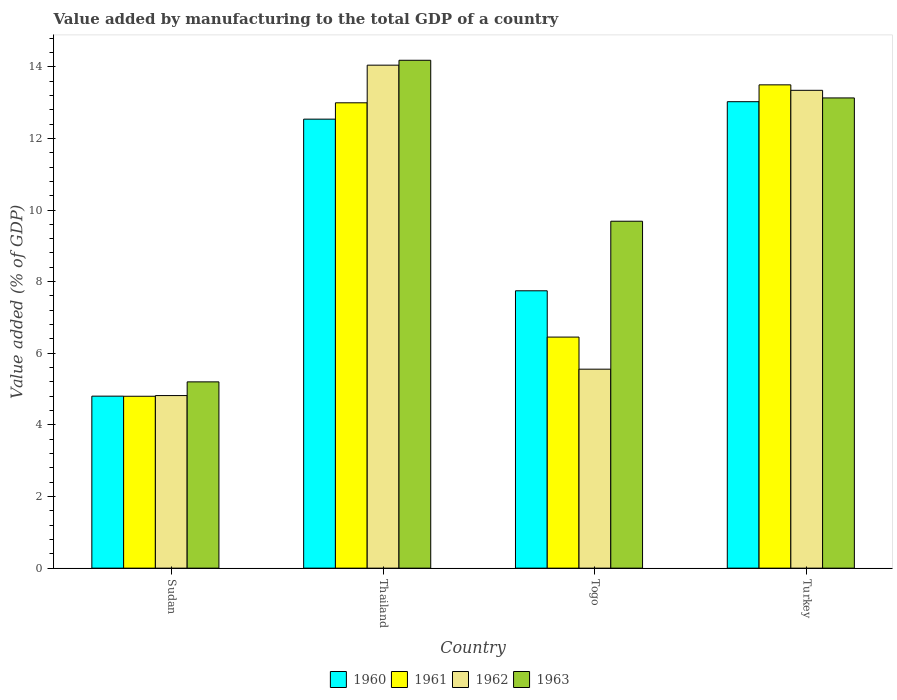How many groups of bars are there?
Your answer should be compact. 4. Are the number of bars per tick equal to the number of legend labels?
Make the answer very short. Yes. What is the label of the 1st group of bars from the left?
Your answer should be very brief. Sudan. What is the value added by manufacturing to the total GDP in 1960 in Turkey?
Make the answer very short. 13.02. Across all countries, what is the maximum value added by manufacturing to the total GDP in 1960?
Give a very brief answer. 13.02. Across all countries, what is the minimum value added by manufacturing to the total GDP in 1963?
Your response must be concise. 5.2. In which country was the value added by manufacturing to the total GDP in 1960 maximum?
Offer a very short reply. Turkey. In which country was the value added by manufacturing to the total GDP in 1962 minimum?
Your response must be concise. Sudan. What is the total value added by manufacturing to the total GDP in 1963 in the graph?
Provide a succinct answer. 42.2. What is the difference between the value added by manufacturing to the total GDP in 1962 in Sudan and that in Thailand?
Offer a very short reply. -9.23. What is the difference between the value added by manufacturing to the total GDP in 1962 in Sudan and the value added by manufacturing to the total GDP in 1960 in Thailand?
Your response must be concise. -7.72. What is the average value added by manufacturing to the total GDP in 1963 per country?
Your answer should be very brief. 10.55. What is the difference between the value added by manufacturing to the total GDP of/in 1961 and value added by manufacturing to the total GDP of/in 1962 in Thailand?
Your answer should be very brief. -1.05. What is the ratio of the value added by manufacturing to the total GDP in 1960 in Sudan to that in Togo?
Your answer should be very brief. 0.62. Is the value added by manufacturing to the total GDP in 1963 in Togo less than that in Turkey?
Keep it short and to the point. Yes. Is the difference between the value added by manufacturing to the total GDP in 1961 in Sudan and Togo greater than the difference between the value added by manufacturing to the total GDP in 1962 in Sudan and Togo?
Offer a terse response. No. What is the difference between the highest and the second highest value added by manufacturing to the total GDP in 1962?
Keep it short and to the point. -7.79. What is the difference between the highest and the lowest value added by manufacturing to the total GDP in 1963?
Your answer should be very brief. 8.98. In how many countries, is the value added by manufacturing to the total GDP in 1961 greater than the average value added by manufacturing to the total GDP in 1961 taken over all countries?
Keep it short and to the point. 2. Is it the case that in every country, the sum of the value added by manufacturing to the total GDP in 1963 and value added by manufacturing to the total GDP in 1961 is greater than the sum of value added by manufacturing to the total GDP in 1962 and value added by manufacturing to the total GDP in 1960?
Your response must be concise. No. What does the 4th bar from the right in Sudan represents?
Give a very brief answer. 1960. How many countries are there in the graph?
Give a very brief answer. 4. What is the difference between two consecutive major ticks on the Y-axis?
Your response must be concise. 2. Does the graph contain any zero values?
Provide a succinct answer. No. Does the graph contain grids?
Offer a terse response. No. What is the title of the graph?
Offer a terse response. Value added by manufacturing to the total GDP of a country. What is the label or title of the Y-axis?
Your answer should be compact. Value added (% of GDP). What is the Value added (% of GDP) of 1960 in Sudan?
Offer a very short reply. 4.8. What is the Value added (% of GDP) of 1961 in Sudan?
Give a very brief answer. 4.8. What is the Value added (% of GDP) of 1962 in Sudan?
Your answer should be compact. 4.82. What is the Value added (% of GDP) of 1963 in Sudan?
Your response must be concise. 5.2. What is the Value added (% of GDP) of 1960 in Thailand?
Your answer should be compact. 12.54. What is the Value added (% of GDP) in 1961 in Thailand?
Keep it short and to the point. 12.99. What is the Value added (% of GDP) of 1962 in Thailand?
Your answer should be very brief. 14.04. What is the Value added (% of GDP) in 1963 in Thailand?
Your answer should be compact. 14.18. What is the Value added (% of GDP) of 1960 in Togo?
Keep it short and to the point. 7.74. What is the Value added (% of GDP) in 1961 in Togo?
Provide a short and direct response. 6.45. What is the Value added (% of GDP) in 1962 in Togo?
Make the answer very short. 5.56. What is the Value added (% of GDP) of 1963 in Togo?
Provide a short and direct response. 9.69. What is the Value added (% of GDP) in 1960 in Turkey?
Your answer should be very brief. 13.02. What is the Value added (% of GDP) in 1961 in Turkey?
Your response must be concise. 13.49. What is the Value added (% of GDP) in 1962 in Turkey?
Your answer should be very brief. 13.34. What is the Value added (% of GDP) of 1963 in Turkey?
Offer a terse response. 13.13. Across all countries, what is the maximum Value added (% of GDP) in 1960?
Make the answer very short. 13.02. Across all countries, what is the maximum Value added (% of GDP) of 1961?
Your answer should be very brief. 13.49. Across all countries, what is the maximum Value added (% of GDP) of 1962?
Your answer should be compact. 14.04. Across all countries, what is the maximum Value added (% of GDP) in 1963?
Provide a short and direct response. 14.18. Across all countries, what is the minimum Value added (% of GDP) of 1960?
Give a very brief answer. 4.8. Across all countries, what is the minimum Value added (% of GDP) of 1961?
Ensure brevity in your answer.  4.8. Across all countries, what is the minimum Value added (% of GDP) of 1962?
Provide a succinct answer. 4.82. Across all countries, what is the minimum Value added (% of GDP) of 1963?
Your answer should be compact. 5.2. What is the total Value added (% of GDP) in 1960 in the graph?
Provide a short and direct response. 38.11. What is the total Value added (% of GDP) of 1961 in the graph?
Keep it short and to the point. 37.74. What is the total Value added (% of GDP) of 1962 in the graph?
Offer a very short reply. 37.76. What is the total Value added (% of GDP) in 1963 in the graph?
Your response must be concise. 42.2. What is the difference between the Value added (% of GDP) in 1960 in Sudan and that in Thailand?
Offer a terse response. -7.73. What is the difference between the Value added (% of GDP) in 1961 in Sudan and that in Thailand?
Provide a short and direct response. -8.19. What is the difference between the Value added (% of GDP) of 1962 in Sudan and that in Thailand?
Your answer should be compact. -9.23. What is the difference between the Value added (% of GDP) in 1963 in Sudan and that in Thailand?
Provide a short and direct response. -8.98. What is the difference between the Value added (% of GDP) in 1960 in Sudan and that in Togo?
Ensure brevity in your answer.  -2.94. What is the difference between the Value added (% of GDP) of 1961 in Sudan and that in Togo?
Provide a succinct answer. -1.65. What is the difference between the Value added (% of GDP) of 1962 in Sudan and that in Togo?
Provide a short and direct response. -0.74. What is the difference between the Value added (% of GDP) of 1963 in Sudan and that in Togo?
Provide a short and direct response. -4.49. What is the difference between the Value added (% of GDP) in 1960 in Sudan and that in Turkey?
Provide a short and direct response. -8.22. What is the difference between the Value added (% of GDP) in 1961 in Sudan and that in Turkey?
Offer a terse response. -8.69. What is the difference between the Value added (% of GDP) of 1962 in Sudan and that in Turkey?
Provide a succinct answer. -8.52. What is the difference between the Value added (% of GDP) of 1963 in Sudan and that in Turkey?
Ensure brevity in your answer.  -7.93. What is the difference between the Value added (% of GDP) of 1960 in Thailand and that in Togo?
Your response must be concise. 4.79. What is the difference between the Value added (% of GDP) of 1961 in Thailand and that in Togo?
Provide a succinct answer. 6.54. What is the difference between the Value added (% of GDP) of 1962 in Thailand and that in Togo?
Ensure brevity in your answer.  8.49. What is the difference between the Value added (% of GDP) in 1963 in Thailand and that in Togo?
Offer a terse response. 4.49. What is the difference between the Value added (% of GDP) of 1960 in Thailand and that in Turkey?
Your answer should be very brief. -0.49. What is the difference between the Value added (% of GDP) in 1961 in Thailand and that in Turkey?
Keep it short and to the point. -0.5. What is the difference between the Value added (% of GDP) of 1962 in Thailand and that in Turkey?
Offer a terse response. 0.7. What is the difference between the Value added (% of GDP) in 1963 in Thailand and that in Turkey?
Make the answer very short. 1.05. What is the difference between the Value added (% of GDP) in 1960 in Togo and that in Turkey?
Provide a succinct answer. -5.28. What is the difference between the Value added (% of GDP) of 1961 in Togo and that in Turkey?
Give a very brief answer. -7.04. What is the difference between the Value added (% of GDP) in 1962 in Togo and that in Turkey?
Give a very brief answer. -7.79. What is the difference between the Value added (% of GDP) of 1963 in Togo and that in Turkey?
Your response must be concise. -3.44. What is the difference between the Value added (% of GDP) of 1960 in Sudan and the Value added (% of GDP) of 1961 in Thailand?
Provide a succinct answer. -8.19. What is the difference between the Value added (% of GDP) of 1960 in Sudan and the Value added (% of GDP) of 1962 in Thailand?
Provide a short and direct response. -9.24. What is the difference between the Value added (% of GDP) in 1960 in Sudan and the Value added (% of GDP) in 1963 in Thailand?
Offer a very short reply. -9.38. What is the difference between the Value added (% of GDP) of 1961 in Sudan and the Value added (% of GDP) of 1962 in Thailand?
Offer a very short reply. -9.24. What is the difference between the Value added (% of GDP) in 1961 in Sudan and the Value added (% of GDP) in 1963 in Thailand?
Make the answer very short. -9.38. What is the difference between the Value added (% of GDP) of 1962 in Sudan and the Value added (% of GDP) of 1963 in Thailand?
Offer a terse response. -9.36. What is the difference between the Value added (% of GDP) in 1960 in Sudan and the Value added (% of GDP) in 1961 in Togo?
Ensure brevity in your answer.  -1.65. What is the difference between the Value added (% of GDP) in 1960 in Sudan and the Value added (% of GDP) in 1962 in Togo?
Provide a succinct answer. -0.75. What is the difference between the Value added (% of GDP) of 1960 in Sudan and the Value added (% of GDP) of 1963 in Togo?
Provide a succinct answer. -4.88. What is the difference between the Value added (% of GDP) in 1961 in Sudan and the Value added (% of GDP) in 1962 in Togo?
Make the answer very short. -0.76. What is the difference between the Value added (% of GDP) of 1961 in Sudan and the Value added (% of GDP) of 1963 in Togo?
Provide a succinct answer. -4.89. What is the difference between the Value added (% of GDP) of 1962 in Sudan and the Value added (% of GDP) of 1963 in Togo?
Make the answer very short. -4.87. What is the difference between the Value added (% of GDP) in 1960 in Sudan and the Value added (% of GDP) in 1961 in Turkey?
Provide a short and direct response. -8.69. What is the difference between the Value added (% of GDP) of 1960 in Sudan and the Value added (% of GDP) of 1962 in Turkey?
Your answer should be very brief. -8.54. What is the difference between the Value added (% of GDP) in 1960 in Sudan and the Value added (% of GDP) in 1963 in Turkey?
Your answer should be very brief. -8.33. What is the difference between the Value added (% of GDP) of 1961 in Sudan and the Value added (% of GDP) of 1962 in Turkey?
Your response must be concise. -8.54. What is the difference between the Value added (% of GDP) in 1961 in Sudan and the Value added (% of GDP) in 1963 in Turkey?
Offer a terse response. -8.33. What is the difference between the Value added (% of GDP) in 1962 in Sudan and the Value added (% of GDP) in 1963 in Turkey?
Offer a terse response. -8.31. What is the difference between the Value added (% of GDP) of 1960 in Thailand and the Value added (% of GDP) of 1961 in Togo?
Ensure brevity in your answer.  6.09. What is the difference between the Value added (% of GDP) of 1960 in Thailand and the Value added (% of GDP) of 1962 in Togo?
Offer a terse response. 6.98. What is the difference between the Value added (% of GDP) of 1960 in Thailand and the Value added (% of GDP) of 1963 in Togo?
Offer a very short reply. 2.85. What is the difference between the Value added (% of GDP) in 1961 in Thailand and the Value added (% of GDP) in 1962 in Togo?
Offer a terse response. 7.44. What is the difference between the Value added (% of GDP) of 1961 in Thailand and the Value added (% of GDP) of 1963 in Togo?
Your response must be concise. 3.31. What is the difference between the Value added (% of GDP) of 1962 in Thailand and the Value added (% of GDP) of 1963 in Togo?
Your response must be concise. 4.36. What is the difference between the Value added (% of GDP) of 1960 in Thailand and the Value added (% of GDP) of 1961 in Turkey?
Offer a terse response. -0.96. What is the difference between the Value added (% of GDP) of 1960 in Thailand and the Value added (% of GDP) of 1962 in Turkey?
Your answer should be compact. -0.81. What is the difference between the Value added (% of GDP) of 1960 in Thailand and the Value added (% of GDP) of 1963 in Turkey?
Your answer should be very brief. -0.59. What is the difference between the Value added (% of GDP) in 1961 in Thailand and the Value added (% of GDP) in 1962 in Turkey?
Offer a terse response. -0.35. What is the difference between the Value added (% of GDP) in 1961 in Thailand and the Value added (% of GDP) in 1963 in Turkey?
Offer a terse response. -0.14. What is the difference between the Value added (% of GDP) of 1962 in Thailand and the Value added (% of GDP) of 1963 in Turkey?
Your answer should be compact. 0.92. What is the difference between the Value added (% of GDP) of 1960 in Togo and the Value added (% of GDP) of 1961 in Turkey?
Your response must be concise. -5.75. What is the difference between the Value added (% of GDP) in 1960 in Togo and the Value added (% of GDP) in 1962 in Turkey?
Your response must be concise. -5.6. What is the difference between the Value added (% of GDP) in 1960 in Togo and the Value added (% of GDP) in 1963 in Turkey?
Provide a succinct answer. -5.38. What is the difference between the Value added (% of GDP) in 1961 in Togo and the Value added (% of GDP) in 1962 in Turkey?
Provide a short and direct response. -6.89. What is the difference between the Value added (% of GDP) in 1961 in Togo and the Value added (% of GDP) in 1963 in Turkey?
Offer a very short reply. -6.68. What is the difference between the Value added (% of GDP) of 1962 in Togo and the Value added (% of GDP) of 1963 in Turkey?
Provide a short and direct response. -7.57. What is the average Value added (% of GDP) of 1960 per country?
Provide a short and direct response. 9.53. What is the average Value added (% of GDP) of 1961 per country?
Offer a terse response. 9.43. What is the average Value added (% of GDP) of 1962 per country?
Keep it short and to the point. 9.44. What is the average Value added (% of GDP) of 1963 per country?
Offer a terse response. 10.55. What is the difference between the Value added (% of GDP) of 1960 and Value added (% of GDP) of 1961 in Sudan?
Your answer should be very brief. 0. What is the difference between the Value added (% of GDP) in 1960 and Value added (% of GDP) in 1962 in Sudan?
Keep it short and to the point. -0.02. What is the difference between the Value added (% of GDP) in 1960 and Value added (% of GDP) in 1963 in Sudan?
Ensure brevity in your answer.  -0.4. What is the difference between the Value added (% of GDP) in 1961 and Value added (% of GDP) in 1962 in Sudan?
Provide a succinct answer. -0.02. What is the difference between the Value added (% of GDP) in 1961 and Value added (% of GDP) in 1963 in Sudan?
Your answer should be very brief. -0.4. What is the difference between the Value added (% of GDP) of 1962 and Value added (% of GDP) of 1963 in Sudan?
Offer a terse response. -0.38. What is the difference between the Value added (% of GDP) in 1960 and Value added (% of GDP) in 1961 in Thailand?
Offer a terse response. -0.46. What is the difference between the Value added (% of GDP) in 1960 and Value added (% of GDP) in 1962 in Thailand?
Provide a succinct answer. -1.51. What is the difference between the Value added (% of GDP) in 1960 and Value added (% of GDP) in 1963 in Thailand?
Provide a succinct answer. -1.64. What is the difference between the Value added (% of GDP) of 1961 and Value added (% of GDP) of 1962 in Thailand?
Provide a succinct answer. -1.05. What is the difference between the Value added (% of GDP) in 1961 and Value added (% of GDP) in 1963 in Thailand?
Make the answer very short. -1.19. What is the difference between the Value added (% of GDP) in 1962 and Value added (% of GDP) in 1963 in Thailand?
Make the answer very short. -0.14. What is the difference between the Value added (% of GDP) in 1960 and Value added (% of GDP) in 1961 in Togo?
Provide a succinct answer. 1.29. What is the difference between the Value added (% of GDP) of 1960 and Value added (% of GDP) of 1962 in Togo?
Offer a very short reply. 2.19. What is the difference between the Value added (% of GDP) of 1960 and Value added (% of GDP) of 1963 in Togo?
Your answer should be very brief. -1.94. What is the difference between the Value added (% of GDP) in 1961 and Value added (% of GDP) in 1962 in Togo?
Make the answer very short. 0.9. What is the difference between the Value added (% of GDP) of 1961 and Value added (% of GDP) of 1963 in Togo?
Your answer should be compact. -3.23. What is the difference between the Value added (% of GDP) of 1962 and Value added (% of GDP) of 1963 in Togo?
Give a very brief answer. -4.13. What is the difference between the Value added (% of GDP) in 1960 and Value added (% of GDP) in 1961 in Turkey?
Keep it short and to the point. -0.47. What is the difference between the Value added (% of GDP) in 1960 and Value added (% of GDP) in 1962 in Turkey?
Your response must be concise. -0.32. What is the difference between the Value added (% of GDP) in 1960 and Value added (% of GDP) in 1963 in Turkey?
Offer a very short reply. -0.11. What is the difference between the Value added (% of GDP) in 1961 and Value added (% of GDP) in 1962 in Turkey?
Offer a very short reply. 0.15. What is the difference between the Value added (% of GDP) in 1961 and Value added (% of GDP) in 1963 in Turkey?
Ensure brevity in your answer.  0.37. What is the difference between the Value added (% of GDP) of 1962 and Value added (% of GDP) of 1963 in Turkey?
Give a very brief answer. 0.21. What is the ratio of the Value added (% of GDP) of 1960 in Sudan to that in Thailand?
Provide a succinct answer. 0.38. What is the ratio of the Value added (% of GDP) of 1961 in Sudan to that in Thailand?
Make the answer very short. 0.37. What is the ratio of the Value added (% of GDP) of 1962 in Sudan to that in Thailand?
Your answer should be compact. 0.34. What is the ratio of the Value added (% of GDP) in 1963 in Sudan to that in Thailand?
Offer a terse response. 0.37. What is the ratio of the Value added (% of GDP) in 1960 in Sudan to that in Togo?
Your response must be concise. 0.62. What is the ratio of the Value added (% of GDP) of 1961 in Sudan to that in Togo?
Keep it short and to the point. 0.74. What is the ratio of the Value added (% of GDP) of 1962 in Sudan to that in Togo?
Provide a short and direct response. 0.87. What is the ratio of the Value added (% of GDP) in 1963 in Sudan to that in Togo?
Keep it short and to the point. 0.54. What is the ratio of the Value added (% of GDP) in 1960 in Sudan to that in Turkey?
Ensure brevity in your answer.  0.37. What is the ratio of the Value added (% of GDP) of 1961 in Sudan to that in Turkey?
Provide a succinct answer. 0.36. What is the ratio of the Value added (% of GDP) of 1962 in Sudan to that in Turkey?
Your answer should be very brief. 0.36. What is the ratio of the Value added (% of GDP) in 1963 in Sudan to that in Turkey?
Offer a terse response. 0.4. What is the ratio of the Value added (% of GDP) in 1960 in Thailand to that in Togo?
Your answer should be compact. 1.62. What is the ratio of the Value added (% of GDP) of 1961 in Thailand to that in Togo?
Your response must be concise. 2.01. What is the ratio of the Value added (% of GDP) of 1962 in Thailand to that in Togo?
Your response must be concise. 2.53. What is the ratio of the Value added (% of GDP) of 1963 in Thailand to that in Togo?
Your answer should be compact. 1.46. What is the ratio of the Value added (% of GDP) in 1960 in Thailand to that in Turkey?
Your answer should be compact. 0.96. What is the ratio of the Value added (% of GDP) in 1961 in Thailand to that in Turkey?
Your response must be concise. 0.96. What is the ratio of the Value added (% of GDP) of 1962 in Thailand to that in Turkey?
Your answer should be compact. 1.05. What is the ratio of the Value added (% of GDP) of 1963 in Thailand to that in Turkey?
Ensure brevity in your answer.  1.08. What is the ratio of the Value added (% of GDP) of 1960 in Togo to that in Turkey?
Your answer should be very brief. 0.59. What is the ratio of the Value added (% of GDP) of 1961 in Togo to that in Turkey?
Your response must be concise. 0.48. What is the ratio of the Value added (% of GDP) of 1962 in Togo to that in Turkey?
Your answer should be very brief. 0.42. What is the ratio of the Value added (% of GDP) in 1963 in Togo to that in Turkey?
Your answer should be compact. 0.74. What is the difference between the highest and the second highest Value added (% of GDP) of 1960?
Your answer should be compact. 0.49. What is the difference between the highest and the second highest Value added (% of GDP) in 1961?
Make the answer very short. 0.5. What is the difference between the highest and the second highest Value added (% of GDP) in 1962?
Your response must be concise. 0.7. What is the difference between the highest and the second highest Value added (% of GDP) of 1963?
Your response must be concise. 1.05. What is the difference between the highest and the lowest Value added (% of GDP) in 1960?
Provide a succinct answer. 8.22. What is the difference between the highest and the lowest Value added (% of GDP) in 1961?
Your answer should be very brief. 8.69. What is the difference between the highest and the lowest Value added (% of GDP) in 1962?
Provide a succinct answer. 9.23. What is the difference between the highest and the lowest Value added (% of GDP) of 1963?
Keep it short and to the point. 8.98. 